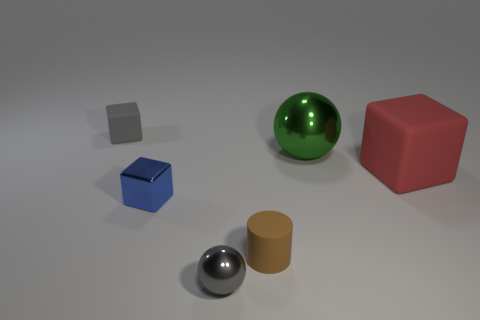Add 2 small green metal cylinders. How many objects exist? 8 Subtract all cylinders. How many objects are left? 5 Add 1 large red matte cubes. How many large red matte cubes exist? 2 Subtract 1 green balls. How many objects are left? 5 Subtract all brown matte objects. Subtract all tiny red matte cylinders. How many objects are left? 5 Add 6 small gray blocks. How many small gray blocks are left? 7 